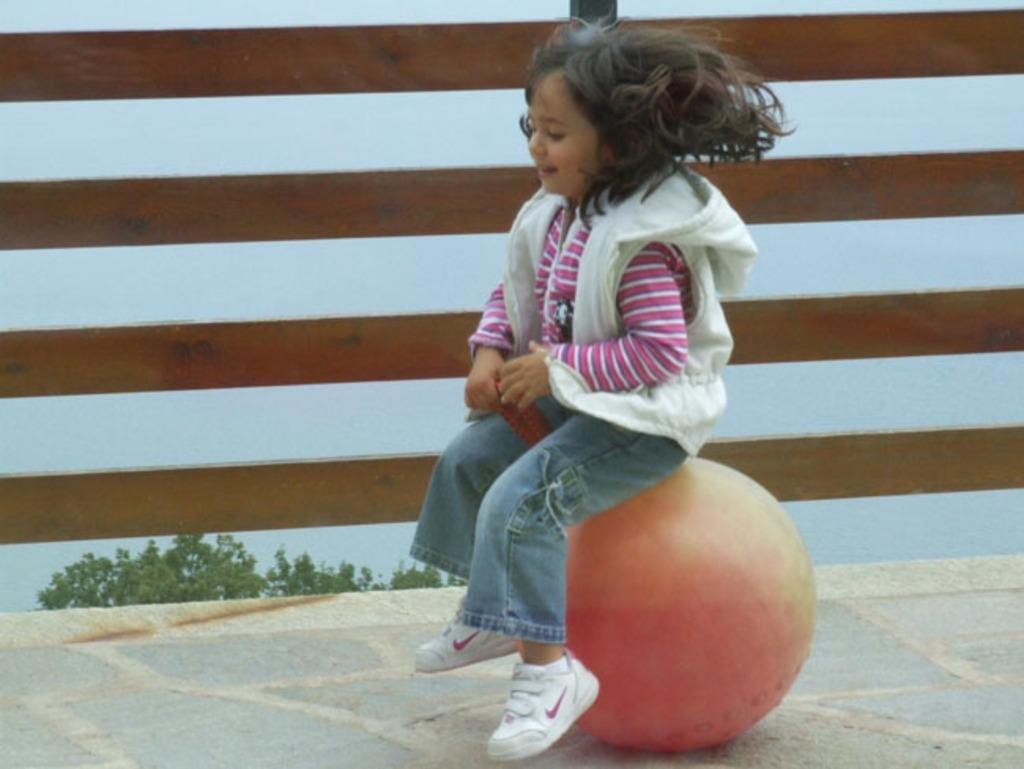Who is the main subject in the image? There is a girl in the image. What is the girl sitting on? The girl is sitting on a round shaped object. What can be seen in the background of the image? There is a wooden fence, a tree, and the sky visible in the background of the image. How does the girl burst into laughter in the image? There is no indication in the image that the girl is laughing or bursting into laughter. 